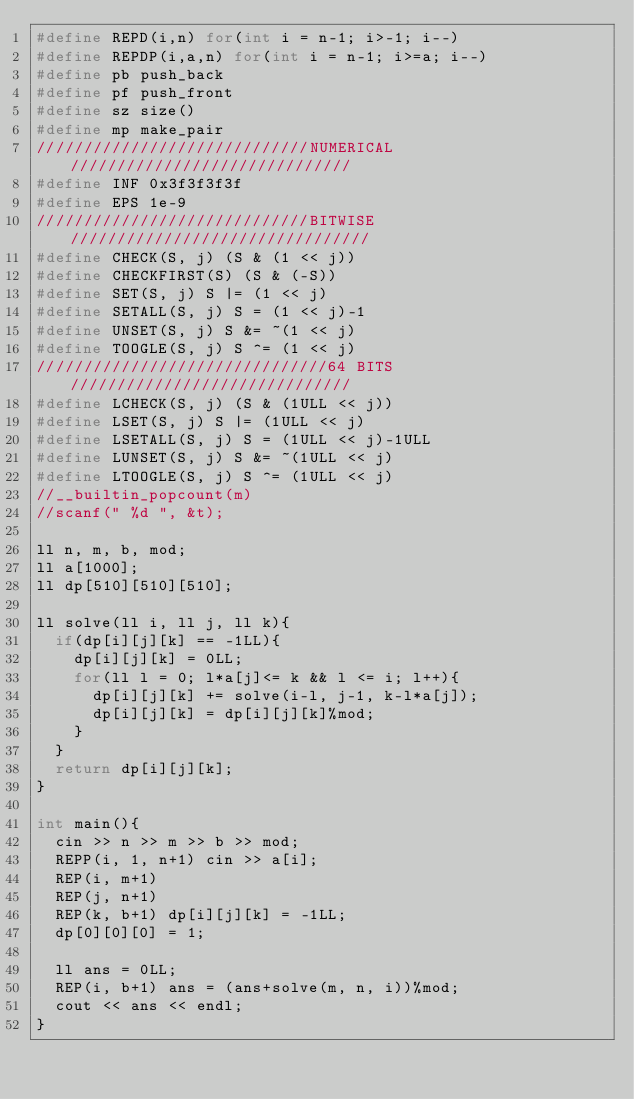Convert code to text. <code><loc_0><loc_0><loc_500><loc_500><_C++_>#define REPD(i,n) for(int i = n-1; i>-1; i--)
#define REPDP(i,a,n) for(int i = n-1; i>=a; i--)
#define pb push_back
#define pf push_front
#define sz size()
#define mp make_pair
/////////////////////////////NUMERICAL//////////////////////////////
#define INF 0x3f3f3f3f
#define EPS 1e-9
/////////////////////////////BITWISE////////////////////////////////
#define CHECK(S, j) (S & (1 << j))
#define CHECKFIRST(S) (S & (-S)) 
#define SET(S, j) S |= (1 << j)
#define SETALL(S, j) S = (1 << j)-1  
#define UNSET(S, j) S &= ~(1 << j)
#define TOOGLE(S, j) S ^= (1 << j)
///////////////////////////////64 BITS//////////////////////////////
#define LCHECK(S, j) (S & (1ULL << j))
#define LSET(S, j) S |= (1ULL << j)
#define LSETALL(S, j) S = (1ULL << j)-1ULL 
#define LUNSET(S, j) S &= ~(1ULL << j)
#define LTOOGLE(S, j) S ^= (1ULL << j)
//__builtin_popcount(m)
//scanf(" %d ", &t);

ll n, m, b, mod;
ll a[1000];
ll dp[510][510][510];

ll solve(ll i, ll j, ll k){
	if(dp[i][j][k] == -1LL){
		dp[i][j][k] = 0LL;
		for(ll l = 0; l*a[j]<= k && l <= i; l++){
			dp[i][j][k] += solve(i-l, j-1, k-l*a[j]);
			dp[i][j][k] = dp[i][j][k]%mod;
		}
	}
	return dp[i][j][k];	
}

int main(){
	cin >> n >> m >> b >> mod;
	REPP(i, 1, n+1) cin >> a[i];
	REP(i, m+1)
	REP(j, n+1)
	REP(k, b+1) dp[i][j][k] = -1LL;
	dp[0][0][0] = 1;

	ll ans = 0LL;
	REP(i, b+1) ans = (ans+solve(m, n, i))%mod;
	cout << ans << endl;
}
</code> 